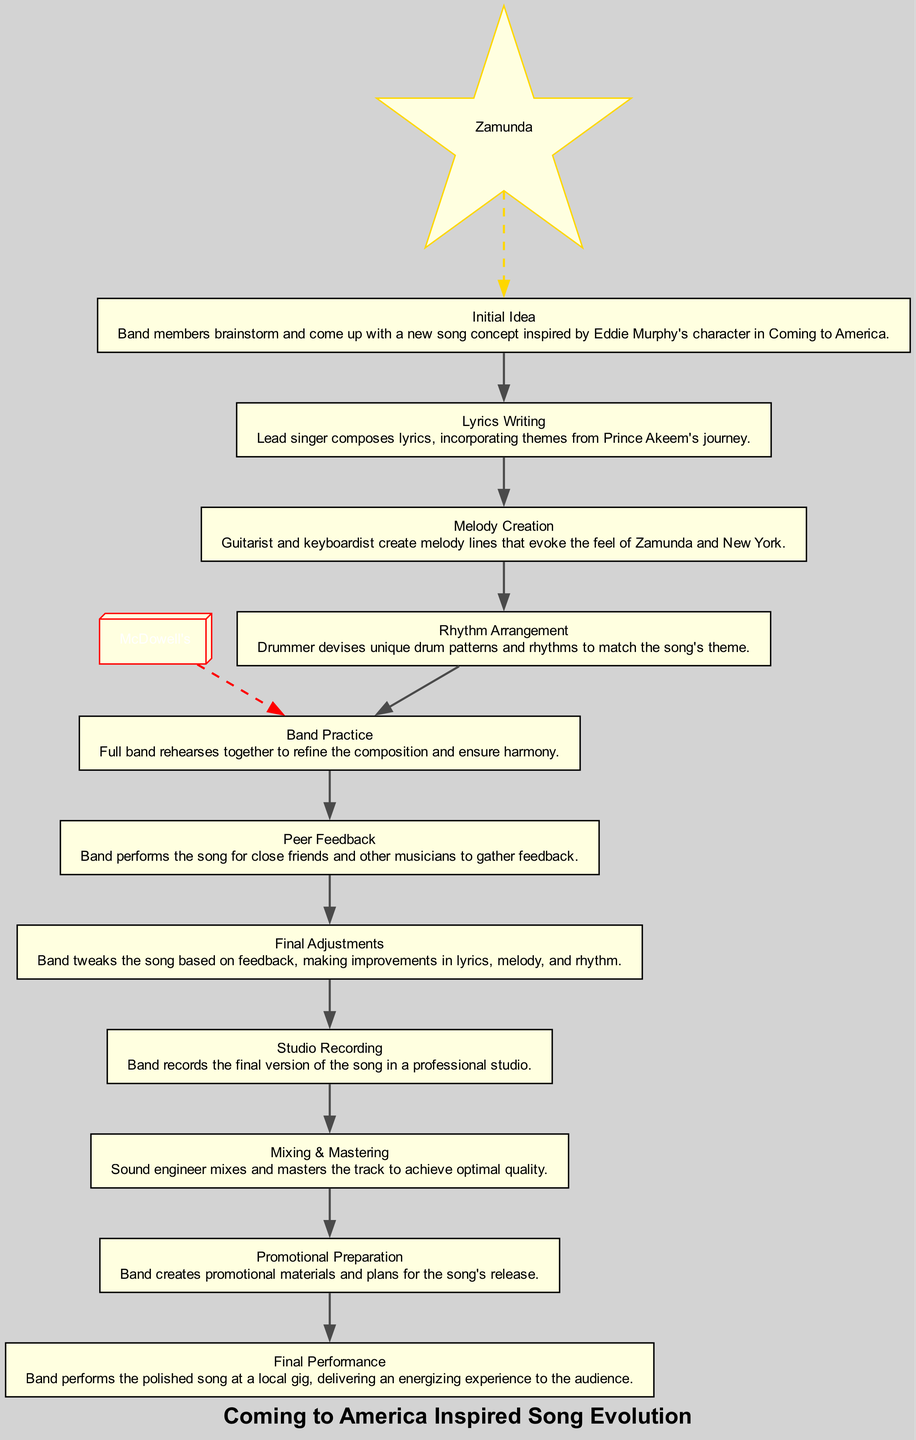What is the first step in the diagram? The first step is "Initial Idea," which is where band members brainstorm and come up with a new song concept.
Answer: Initial Idea How many steps are there in total? The diagram lists 11 steps that track the evolution of the song from concept to performance.
Answer: 11 What step directly follows "Lyrics Writing"? "Melody Creation" is the step that follows "Lyrics Writing" in the flow of song development.
Answer: Melody Creation Which step involves performing the song for feedback? The "Peer Feedback" step involves the band performing the song for close friends and other musicians to gather feedback.
Answer: Peer Feedback How does the diagram visually represent the connection between Zamunda and the song concept? Zamunda is connected to the "Initial Idea" step with a dashed golden edge, suggesting that the inspiration for the song concept comes from Zamunda.
Answer: Dashed golden edge What does the step "Final Performance" signify? "Final Performance" signifies the final stage where the band performs the polished song at a local gig, delivering an energizing experience to the audience.
Answer: Final Performance Which two steps are associated with the arrangement of the song? "Rhythm Arrangement" and "Melody Creation" are both associated with arranging the song, focusing on the rhythm and melody respectively.
Answer: Rhythm Arrangement and Melody Creation In what step does mixing and mastering take place? The step where mixing and mastering occur is titled "Mixing & Mastering," which is essential for achieving optimal sound quality.
Answer: Mixing & Mastering What color is used to represent the node for "McDowell's"? The node for "McDowell's" is represented in red, indicating its distinction within the flowchart.
Answer: Red 